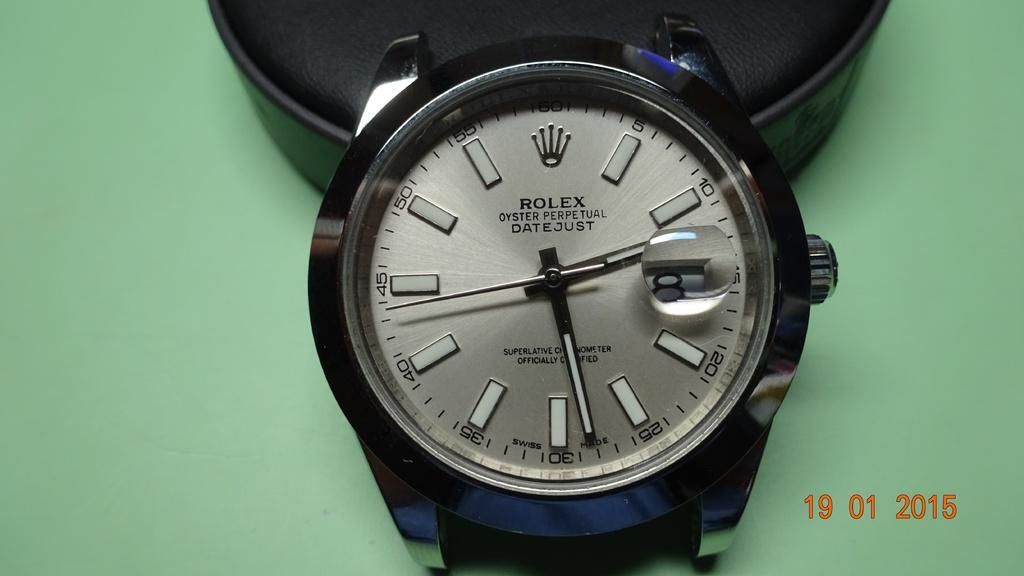What type of object is in the image? There is a watch in the image. What color is the object next to the watch? There is a black object in the image. What is the color of the surface on which the objects are placed? The objects are on a green surface. Where can the date be seen in the image? The date is visible in the bottom right side of the image. How many men are visible in the image? There are no men present in the image. What type of insects can be seen crawling on the watch in the image? There are no insects, such as ants, present in the image. 